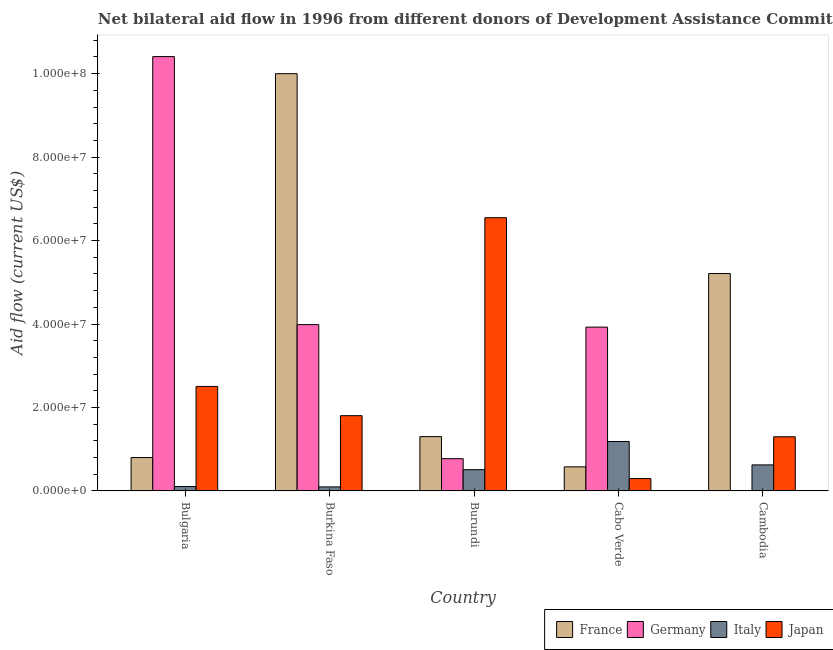How many different coloured bars are there?
Provide a short and direct response. 4. Are the number of bars on each tick of the X-axis equal?
Make the answer very short. Yes. What is the label of the 2nd group of bars from the left?
Provide a short and direct response. Burkina Faso. In how many cases, is the number of bars for a given country not equal to the number of legend labels?
Offer a very short reply. 0. What is the amount of aid given by germany in Burundi?
Keep it short and to the point. 7.73e+06. Across all countries, what is the maximum amount of aid given by japan?
Your response must be concise. 6.55e+07. Across all countries, what is the minimum amount of aid given by france?
Provide a succinct answer. 5.77e+06. In which country was the amount of aid given by germany maximum?
Your answer should be very brief. Bulgaria. In which country was the amount of aid given by france minimum?
Ensure brevity in your answer.  Cabo Verde. What is the total amount of aid given by italy in the graph?
Make the answer very short. 2.52e+07. What is the difference between the amount of aid given by italy in Bulgaria and that in Burkina Faso?
Provide a short and direct response. 8.00e+04. What is the difference between the amount of aid given by japan in Burundi and the amount of aid given by germany in Cabo Verde?
Offer a terse response. 2.62e+07. What is the average amount of aid given by germany per country?
Offer a very short reply. 3.82e+07. What is the difference between the amount of aid given by japan and amount of aid given by italy in Bulgaria?
Your answer should be very brief. 2.40e+07. In how many countries, is the amount of aid given by france greater than 16000000 US$?
Make the answer very short. 2. What is the ratio of the amount of aid given by japan in Burkina Faso to that in Cabo Verde?
Your answer should be very brief. 6.09. What is the difference between the highest and the second highest amount of aid given by italy?
Your answer should be very brief. 5.61e+06. What is the difference between the highest and the lowest amount of aid given by japan?
Offer a very short reply. 6.25e+07. In how many countries, is the amount of aid given by france greater than the average amount of aid given by france taken over all countries?
Make the answer very short. 2. Is it the case that in every country, the sum of the amount of aid given by france and amount of aid given by italy is greater than the sum of amount of aid given by germany and amount of aid given by japan?
Ensure brevity in your answer.  No. What does the 1st bar from the left in Burkina Faso represents?
Your answer should be compact. France. What does the 2nd bar from the right in Bulgaria represents?
Your answer should be compact. Italy. Where does the legend appear in the graph?
Keep it short and to the point. Bottom right. How many legend labels are there?
Provide a short and direct response. 4. How are the legend labels stacked?
Offer a terse response. Horizontal. What is the title of the graph?
Your answer should be very brief. Net bilateral aid flow in 1996 from different donors of Development Assistance Committee. Does "Insurance services" appear as one of the legend labels in the graph?
Provide a succinct answer. No. What is the Aid flow (current US$) of Germany in Bulgaria?
Offer a terse response. 1.04e+08. What is the Aid flow (current US$) of Italy in Bulgaria?
Ensure brevity in your answer.  1.05e+06. What is the Aid flow (current US$) of Japan in Bulgaria?
Your response must be concise. 2.50e+07. What is the Aid flow (current US$) in France in Burkina Faso?
Give a very brief answer. 1.00e+08. What is the Aid flow (current US$) in Germany in Burkina Faso?
Offer a very short reply. 3.99e+07. What is the Aid flow (current US$) of Italy in Burkina Faso?
Provide a short and direct response. 9.70e+05. What is the Aid flow (current US$) in Japan in Burkina Faso?
Provide a short and direct response. 1.80e+07. What is the Aid flow (current US$) in France in Burundi?
Your response must be concise. 1.30e+07. What is the Aid flow (current US$) of Germany in Burundi?
Provide a short and direct response. 7.73e+06. What is the Aid flow (current US$) in Italy in Burundi?
Your answer should be compact. 5.10e+06. What is the Aid flow (current US$) in Japan in Burundi?
Provide a short and direct response. 6.55e+07. What is the Aid flow (current US$) of France in Cabo Verde?
Make the answer very short. 5.77e+06. What is the Aid flow (current US$) in Germany in Cabo Verde?
Provide a short and direct response. 3.93e+07. What is the Aid flow (current US$) of Italy in Cabo Verde?
Make the answer very short. 1.18e+07. What is the Aid flow (current US$) in Japan in Cabo Verde?
Give a very brief answer. 2.96e+06. What is the Aid flow (current US$) of France in Cambodia?
Keep it short and to the point. 5.21e+07. What is the Aid flow (current US$) of Germany in Cambodia?
Your answer should be compact. 2.00e+04. What is the Aid flow (current US$) in Italy in Cambodia?
Give a very brief answer. 6.24e+06. What is the Aid flow (current US$) in Japan in Cambodia?
Offer a terse response. 1.30e+07. Across all countries, what is the maximum Aid flow (current US$) of France?
Your response must be concise. 1.00e+08. Across all countries, what is the maximum Aid flow (current US$) of Germany?
Offer a very short reply. 1.04e+08. Across all countries, what is the maximum Aid flow (current US$) of Italy?
Your answer should be very brief. 1.18e+07. Across all countries, what is the maximum Aid flow (current US$) of Japan?
Your answer should be compact. 6.55e+07. Across all countries, what is the minimum Aid flow (current US$) of France?
Provide a short and direct response. 5.77e+06. Across all countries, what is the minimum Aid flow (current US$) in Germany?
Offer a very short reply. 2.00e+04. Across all countries, what is the minimum Aid flow (current US$) of Italy?
Give a very brief answer. 9.70e+05. Across all countries, what is the minimum Aid flow (current US$) in Japan?
Ensure brevity in your answer.  2.96e+06. What is the total Aid flow (current US$) in France in the graph?
Offer a very short reply. 1.79e+08. What is the total Aid flow (current US$) in Germany in the graph?
Provide a succinct answer. 1.91e+08. What is the total Aid flow (current US$) in Italy in the graph?
Give a very brief answer. 2.52e+07. What is the total Aid flow (current US$) in Japan in the graph?
Provide a short and direct response. 1.24e+08. What is the difference between the Aid flow (current US$) in France in Bulgaria and that in Burkina Faso?
Keep it short and to the point. -9.20e+07. What is the difference between the Aid flow (current US$) of Germany in Bulgaria and that in Burkina Faso?
Give a very brief answer. 6.42e+07. What is the difference between the Aid flow (current US$) of France in Bulgaria and that in Burundi?
Offer a very short reply. -5.02e+06. What is the difference between the Aid flow (current US$) of Germany in Bulgaria and that in Burundi?
Make the answer very short. 9.64e+07. What is the difference between the Aid flow (current US$) of Italy in Bulgaria and that in Burundi?
Your response must be concise. -4.05e+06. What is the difference between the Aid flow (current US$) of Japan in Bulgaria and that in Burundi?
Keep it short and to the point. -4.04e+07. What is the difference between the Aid flow (current US$) of France in Bulgaria and that in Cabo Verde?
Your answer should be very brief. 2.23e+06. What is the difference between the Aid flow (current US$) in Germany in Bulgaria and that in Cabo Verde?
Keep it short and to the point. 6.48e+07. What is the difference between the Aid flow (current US$) of Italy in Bulgaria and that in Cabo Verde?
Provide a short and direct response. -1.08e+07. What is the difference between the Aid flow (current US$) in Japan in Bulgaria and that in Cabo Verde?
Offer a terse response. 2.21e+07. What is the difference between the Aid flow (current US$) in France in Bulgaria and that in Cambodia?
Ensure brevity in your answer.  -4.41e+07. What is the difference between the Aid flow (current US$) of Germany in Bulgaria and that in Cambodia?
Your answer should be very brief. 1.04e+08. What is the difference between the Aid flow (current US$) of Italy in Bulgaria and that in Cambodia?
Offer a terse response. -5.19e+06. What is the difference between the Aid flow (current US$) in Japan in Bulgaria and that in Cambodia?
Give a very brief answer. 1.21e+07. What is the difference between the Aid flow (current US$) of France in Burkina Faso and that in Burundi?
Your answer should be compact. 8.70e+07. What is the difference between the Aid flow (current US$) in Germany in Burkina Faso and that in Burundi?
Provide a succinct answer. 3.21e+07. What is the difference between the Aid flow (current US$) of Italy in Burkina Faso and that in Burundi?
Provide a short and direct response. -4.13e+06. What is the difference between the Aid flow (current US$) in Japan in Burkina Faso and that in Burundi?
Provide a succinct answer. -4.74e+07. What is the difference between the Aid flow (current US$) of France in Burkina Faso and that in Cabo Verde?
Ensure brevity in your answer.  9.42e+07. What is the difference between the Aid flow (current US$) of Germany in Burkina Faso and that in Cabo Verde?
Make the answer very short. 6.00e+05. What is the difference between the Aid flow (current US$) in Italy in Burkina Faso and that in Cabo Verde?
Your answer should be very brief. -1.09e+07. What is the difference between the Aid flow (current US$) in Japan in Burkina Faso and that in Cabo Verde?
Ensure brevity in your answer.  1.51e+07. What is the difference between the Aid flow (current US$) of France in Burkina Faso and that in Cambodia?
Your response must be concise. 4.79e+07. What is the difference between the Aid flow (current US$) of Germany in Burkina Faso and that in Cambodia?
Provide a succinct answer. 3.98e+07. What is the difference between the Aid flow (current US$) of Italy in Burkina Faso and that in Cambodia?
Your answer should be very brief. -5.27e+06. What is the difference between the Aid flow (current US$) of Japan in Burkina Faso and that in Cambodia?
Your answer should be compact. 5.06e+06. What is the difference between the Aid flow (current US$) of France in Burundi and that in Cabo Verde?
Offer a very short reply. 7.25e+06. What is the difference between the Aid flow (current US$) of Germany in Burundi and that in Cabo Verde?
Your response must be concise. -3.15e+07. What is the difference between the Aid flow (current US$) in Italy in Burundi and that in Cabo Verde?
Keep it short and to the point. -6.75e+06. What is the difference between the Aid flow (current US$) of Japan in Burundi and that in Cabo Verde?
Give a very brief answer. 6.25e+07. What is the difference between the Aid flow (current US$) of France in Burundi and that in Cambodia?
Your answer should be very brief. -3.91e+07. What is the difference between the Aid flow (current US$) in Germany in Burundi and that in Cambodia?
Provide a succinct answer. 7.71e+06. What is the difference between the Aid flow (current US$) in Italy in Burundi and that in Cambodia?
Keep it short and to the point. -1.14e+06. What is the difference between the Aid flow (current US$) in Japan in Burundi and that in Cambodia?
Ensure brevity in your answer.  5.25e+07. What is the difference between the Aid flow (current US$) in France in Cabo Verde and that in Cambodia?
Your answer should be compact. -4.63e+07. What is the difference between the Aid flow (current US$) in Germany in Cabo Verde and that in Cambodia?
Provide a short and direct response. 3.92e+07. What is the difference between the Aid flow (current US$) of Italy in Cabo Verde and that in Cambodia?
Provide a short and direct response. 5.61e+06. What is the difference between the Aid flow (current US$) in Japan in Cabo Verde and that in Cambodia?
Ensure brevity in your answer.  -1.00e+07. What is the difference between the Aid flow (current US$) in France in Bulgaria and the Aid flow (current US$) in Germany in Burkina Faso?
Offer a very short reply. -3.19e+07. What is the difference between the Aid flow (current US$) in France in Bulgaria and the Aid flow (current US$) in Italy in Burkina Faso?
Ensure brevity in your answer.  7.03e+06. What is the difference between the Aid flow (current US$) of France in Bulgaria and the Aid flow (current US$) of Japan in Burkina Faso?
Your answer should be compact. -1.00e+07. What is the difference between the Aid flow (current US$) of Germany in Bulgaria and the Aid flow (current US$) of Italy in Burkina Faso?
Keep it short and to the point. 1.03e+08. What is the difference between the Aid flow (current US$) of Germany in Bulgaria and the Aid flow (current US$) of Japan in Burkina Faso?
Your answer should be compact. 8.60e+07. What is the difference between the Aid flow (current US$) of Italy in Bulgaria and the Aid flow (current US$) of Japan in Burkina Faso?
Offer a very short reply. -1.70e+07. What is the difference between the Aid flow (current US$) in France in Bulgaria and the Aid flow (current US$) in Italy in Burundi?
Offer a terse response. 2.90e+06. What is the difference between the Aid flow (current US$) in France in Bulgaria and the Aid flow (current US$) in Japan in Burundi?
Provide a short and direct response. -5.75e+07. What is the difference between the Aid flow (current US$) in Germany in Bulgaria and the Aid flow (current US$) in Italy in Burundi?
Offer a terse response. 9.90e+07. What is the difference between the Aid flow (current US$) in Germany in Bulgaria and the Aid flow (current US$) in Japan in Burundi?
Give a very brief answer. 3.86e+07. What is the difference between the Aid flow (current US$) in Italy in Bulgaria and the Aid flow (current US$) in Japan in Burundi?
Make the answer very short. -6.44e+07. What is the difference between the Aid flow (current US$) of France in Bulgaria and the Aid flow (current US$) of Germany in Cabo Verde?
Your answer should be very brief. -3.13e+07. What is the difference between the Aid flow (current US$) in France in Bulgaria and the Aid flow (current US$) in Italy in Cabo Verde?
Your response must be concise. -3.85e+06. What is the difference between the Aid flow (current US$) in France in Bulgaria and the Aid flow (current US$) in Japan in Cabo Verde?
Offer a terse response. 5.04e+06. What is the difference between the Aid flow (current US$) of Germany in Bulgaria and the Aid flow (current US$) of Italy in Cabo Verde?
Offer a terse response. 9.22e+07. What is the difference between the Aid flow (current US$) of Germany in Bulgaria and the Aid flow (current US$) of Japan in Cabo Verde?
Your answer should be very brief. 1.01e+08. What is the difference between the Aid flow (current US$) in Italy in Bulgaria and the Aid flow (current US$) in Japan in Cabo Verde?
Make the answer very short. -1.91e+06. What is the difference between the Aid flow (current US$) in France in Bulgaria and the Aid flow (current US$) in Germany in Cambodia?
Provide a short and direct response. 7.98e+06. What is the difference between the Aid flow (current US$) of France in Bulgaria and the Aid flow (current US$) of Italy in Cambodia?
Offer a terse response. 1.76e+06. What is the difference between the Aid flow (current US$) in France in Bulgaria and the Aid flow (current US$) in Japan in Cambodia?
Keep it short and to the point. -4.98e+06. What is the difference between the Aid flow (current US$) in Germany in Bulgaria and the Aid flow (current US$) in Italy in Cambodia?
Offer a terse response. 9.78e+07. What is the difference between the Aid flow (current US$) in Germany in Bulgaria and the Aid flow (current US$) in Japan in Cambodia?
Provide a succinct answer. 9.11e+07. What is the difference between the Aid flow (current US$) in Italy in Bulgaria and the Aid flow (current US$) in Japan in Cambodia?
Keep it short and to the point. -1.19e+07. What is the difference between the Aid flow (current US$) in France in Burkina Faso and the Aid flow (current US$) in Germany in Burundi?
Provide a succinct answer. 9.23e+07. What is the difference between the Aid flow (current US$) in France in Burkina Faso and the Aid flow (current US$) in Italy in Burundi?
Make the answer very short. 9.49e+07. What is the difference between the Aid flow (current US$) in France in Burkina Faso and the Aid flow (current US$) in Japan in Burundi?
Offer a very short reply. 3.45e+07. What is the difference between the Aid flow (current US$) of Germany in Burkina Faso and the Aid flow (current US$) of Italy in Burundi?
Make the answer very short. 3.48e+07. What is the difference between the Aid flow (current US$) in Germany in Burkina Faso and the Aid flow (current US$) in Japan in Burundi?
Your answer should be compact. -2.56e+07. What is the difference between the Aid flow (current US$) in Italy in Burkina Faso and the Aid flow (current US$) in Japan in Burundi?
Provide a succinct answer. -6.45e+07. What is the difference between the Aid flow (current US$) in France in Burkina Faso and the Aid flow (current US$) in Germany in Cabo Verde?
Provide a short and direct response. 6.07e+07. What is the difference between the Aid flow (current US$) of France in Burkina Faso and the Aid flow (current US$) of Italy in Cabo Verde?
Give a very brief answer. 8.82e+07. What is the difference between the Aid flow (current US$) in France in Burkina Faso and the Aid flow (current US$) in Japan in Cabo Verde?
Provide a short and direct response. 9.70e+07. What is the difference between the Aid flow (current US$) of Germany in Burkina Faso and the Aid flow (current US$) of Italy in Cabo Verde?
Give a very brief answer. 2.80e+07. What is the difference between the Aid flow (current US$) in Germany in Burkina Faso and the Aid flow (current US$) in Japan in Cabo Verde?
Provide a short and direct response. 3.69e+07. What is the difference between the Aid flow (current US$) of Italy in Burkina Faso and the Aid flow (current US$) of Japan in Cabo Verde?
Your response must be concise. -1.99e+06. What is the difference between the Aid flow (current US$) in France in Burkina Faso and the Aid flow (current US$) in Germany in Cambodia?
Offer a terse response. 1.00e+08. What is the difference between the Aid flow (current US$) in France in Burkina Faso and the Aid flow (current US$) in Italy in Cambodia?
Give a very brief answer. 9.38e+07. What is the difference between the Aid flow (current US$) in France in Burkina Faso and the Aid flow (current US$) in Japan in Cambodia?
Provide a short and direct response. 8.70e+07. What is the difference between the Aid flow (current US$) in Germany in Burkina Faso and the Aid flow (current US$) in Italy in Cambodia?
Ensure brevity in your answer.  3.36e+07. What is the difference between the Aid flow (current US$) in Germany in Burkina Faso and the Aid flow (current US$) in Japan in Cambodia?
Ensure brevity in your answer.  2.69e+07. What is the difference between the Aid flow (current US$) of Italy in Burkina Faso and the Aid flow (current US$) of Japan in Cambodia?
Your answer should be compact. -1.20e+07. What is the difference between the Aid flow (current US$) of France in Burundi and the Aid flow (current US$) of Germany in Cabo Verde?
Offer a very short reply. -2.62e+07. What is the difference between the Aid flow (current US$) of France in Burundi and the Aid flow (current US$) of Italy in Cabo Verde?
Offer a terse response. 1.17e+06. What is the difference between the Aid flow (current US$) of France in Burundi and the Aid flow (current US$) of Japan in Cabo Verde?
Provide a short and direct response. 1.01e+07. What is the difference between the Aid flow (current US$) in Germany in Burundi and the Aid flow (current US$) in Italy in Cabo Verde?
Provide a succinct answer. -4.12e+06. What is the difference between the Aid flow (current US$) in Germany in Burundi and the Aid flow (current US$) in Japan in Cabo Verde?
Make the answer very short. 4.77e+06. What is the difference between the Aid flow (current US$) in Italy in Burundi and the Aid flow (current US$) in Japan in Cabo Verde?
Provide a short and direct response. 2.14e+06. What is the difference between the Aid flow (current US$) in France in Burundi and the Aid flow (current US$) in Germany in Cambodia?
Offer a very short reply. 1.30e+07. What is the difference between the Aid flow (current US$) in France in Burundi and the Aid flow (current US$) in Italy in Cambodia?
Your answer should be compact. 6.78e+06. What is the difference between the Aid flow (current US$) of France in Burundi and the Aid flow (current US$) of Japan in Cambodia?
Your response must be concise. 4.00e+04. What is the difference between the Aid flow (current US$) in Germany in Burundi and the Aid flow (current US$) in Italy in Cambodia?
Your answer should be compact. 1.49e+06. What is the difference between the Aid flow (current US$) in Germany in Burundi and the Aid flow (current US$) in Japan in Cambodia?
Provide a short and direct response. -5.25e+06. What is the difference between the Aid flow (current US$) in Italy in Burundi and the Aid flow (current US$) in Japan in Cambodia?
Offer a very short reply. -7.88e+06. What is the difference between the Aid flow (current US$) in France in Cabo Verde and the Aid flow (current US$) in Germany in Cambodia?
Provide a succinct answer. 5.75e+06. What is the difference between the Aid flow (current US$) in France in Cabo Verde and the Aid flow (current US$) in Italy in Cambodia?
Provide a succinct answer. -4.70e+05. What is the difference between the Aid flow (current US$) of France in Cabo Verde and the Aid flow (current US$) of Japan in Cambodia?
Ensure brevity in your answer.  -7.21e+06. What is the difference between the Aid flow (current US$) in Germany in Cabo Verde and the Aid flow (current US$) in Italy in Cambodia?
Offer a very short reply. 3.30e+07. What is the difference between the Aid flow (current US$) of Germany in Cabo Verde and the Aid flow (current US$) of Japan in Cambodia?
Ensure brevity in your answer.  2.63e+07. What is the difference between the Aid flow (current US$) in Italy in Cabo Verde and the Aid flow (current US$) in Japan in Cambodia?
Offer a very short reply. -1.13e+06. What is the average Aid flow (current US$) in France per country?
Make the answer very short. 3.58e+07. What is the average Aid flow (current US$) of Germany per country?
Your answer should be compact. 3.82e+07. What is the average Aid flow (current US$) in Italy per country?
Offer a terse response. 5.04e+06. What is the average Aid flow (current US$) of Japan per country?
Offer a terse response. 2.49e+07. What is the difference between the Aid flow (current US$) of France and Aid flow (current US$) of Germany in Bulgaria?
Make the answer very short. -9.61e+07. What is the difference between the Aid flow (current US$) in France and Aid flow (current US$) in Italy in Bulgaria?
Offer a terse response. 6.95e+06. What is the difference between the Aid flow (current US$) of France and Aid flow (current US$) of Japan in Bulgaria?
Offer a terse response. -1.70e+07. What is the difference between the Aid flow (current US$) of Germany and Aid flow (current US$) of Italy in Bulgaria?
Make the answer very short. 1.03e+08. What is the difference between the Aid flow (current US$) of Germany and Aid flow (current US$) of Japan in Bulgaria?
Keep it short and to the point. 7.90e+07. What is the difference between the Aid flow (current US$) of Italy and Aid flow (current US$) of Japan in Bulgaria?
Offer a very short reply. -2.40e+07. What is the difference between the Aid flow (current US$) of France and Aid flow (current US$) of Germany in Burkina Faso?
Your answer should be compact. 6.01e+07. What is the difference between the Aid flow (current US$) in France and Aid flow (current US$) in Italy in Burkina Faso?
Provide a short and direct response. 9.90e+07. What is the difference between the Aid flow (current US$) in France and Aid flow (current US$) in Japan in Burkina Faso?
Your response must be concise. 8.20e+07. What is the difference between the Aid flow (current US$) of Germany and Aid flow (current US$) of Italy in Burkina Faso?
Ensure brevity in your answer.  3.89e+07. What is the difference between the Aid flow (current US$) of Germany and Aid flow (current US$) of Japan in Burkina Faso?
Your response must be concise. 2.18e+07. What is the difference between the Aid flow (current US$) in Italy and Aid flow (current US$) in Japan in Burkina Faso?
Give a very brief answer. -1.71e+07. What is the difference between the Aid flow (current US$) in France and Aid flow (current US$) in Germany in Burundi?
Your answer should be very brief. 5.29e+06. What is the difference between the Aid flow (current US$) of France and Aid flow (current US$) of Italy in Burundi?
Give a very brief answer. 7.92e+06. What is the difference between the Aid flow (current US$) in France and Aid flow (current US$) in Japan in Burundi?
Ensure brevity in your answer.  -5.25e+07. What is the difference between the Aid flow (current US$) in Germany and Aid flow (current US$) in Italy in Burundi?
Your answer should be compact. 2.63e+06. What is the difference between the Aid flow (current US$) in Germany and Aid flow (current US$) in Japan in Burundi?
Your answer should be compact. -5.78e+07. What is the difference between the Aid flow (current US$) of Italy and Aid flow (current US$) of Japan in Burundi?
Your answer should be very brief. -6.04e+07. What is the difference between the Aid flow (current US$) in France and Aid flow (current US$) in Germany in Cabo Verde?
Your answer should be very brief. -3.35e+07. What is the difference between the Aid flow (current US$) in France and Aid flow (current US$) in Italy in Cabo Verde?
Your answer should be very brief. -6.08e+06. What is the difference between the Aid flow (current US$) of France and Aid flow (current US$) of Japan in Cabo Verde?
Provide a succinct answer. 2.81e+06. What is the difference between the Aid flow (current US$) in Germany and Aid flow (current US$) in Italy in Cabo Verde?
Your answer should be very brief. 2.74e+07. What is the difference between the Aid flow (current US$) in Germany and Aid flow (current US$) in Japan in Cabo Verde?
Provide a succinct answer. 3.63e+07. What is the difference between the Aid flow (current US$) in Italy and Aid flow (current US$) in Japan in Cabo Verde?
Your answer should be very brief. 8.89e+06. What is the difference between the Aid flow (current US$) in France and Aid flow (current US$) in Germany in Cambodia?
Ensure brevity in your answer.  5.21e+07. What is the difference between the Aid flow (current US$) of France and Aid flow (current US$) of Italy in Cambodia?
Make the answer very short. 4.59e+07. What is the difference between the Aid flow (current US$) of France and Aid flow (current US$) of Japan in Cambodia?
Your answer should be very brief. 3.91e+07. What is the difference between the Aid flow (current US$) in Germany and Aid flow (current US$) in Italy in Cambodia?
Your answer should be very brief. -6.22e+06. What is the difference between the Aid flow (current US$) in Germany and Aid flow (current US$) in Japan in Cambodia?
Give a very brief answer. -1.30e+07. What is the difference between the Aid flow (current US$) of Italy and Aid flow (current US$) of Japan in Cambodia?
Offer a terse response. -6.74e+06. What is the ratio of the Aid flow (current US$) in Germany in Bulgaria to that in Burkina Faso?
Keep it short and to the point. 2.61. What is the ratio of the Aid flow (current US$) in Italy in Bulgaria to that in Burkina Faso?
Offer a terse response. 1.08. What is the ratio of the Aid flow (current US$) of Japan in Bulgaria to that in Burkina Faso?
Your answer should be compact. 1.39. What is the ratio of the Aid flow (current US$) in France in Bulgaria to that in Burundi?
Offer a very short reply. 0.61. What is the ratio of the Aid flow (current US$) in Germany in Bulgaria to that in Burundi?
Your answer should be compact. 13.47. What is the ratio of the Aid flow (current US$) in Italy in Bulgaria to that in Burundi?
Your answer should be compact. 0.21. What is the ratio of the Aid flow (current US$) in Japan in Bulgaria to that in Burundi?
Make the answer very short. 0.38. What is the ratio of the Aid flow (current US$) in France in Bulgaria to that in Cabo Verde?
Offer a very short reply. 1.39. What is the ratio of the Aid flow (current US$) in Germany in Bulgaria to that in Cabo Verde?
Offer a very short reply. 2.65. What is the ratio of the Aid flow (current US$) of Italy in Bulgaria to that in Cabo Verde?
Give a very brief answer. 0.09. What is the ratio of the Aid flow (current US$) of Japan in Bulgaria to that in Cabo Verde?
Keep it short and to the point. 8.46. What is the ratio of the Aid flow (current US$) of France in Bulgaria to that in Cambodia?
Keep it short and to the point. 0.15. What is the ratio of the Aid flow (current US$) in Germany in Bulgaria to that in Cambodia?
Keep it short and to the point. 5204.5. What is the ratio of the Aid flow (current US$) of Italy in Bulgaria to that in Cambodia?
Ensure brevity in your answer.  0.17. What is the ratio of the Aid flow (current US$) of Japan in Bulgaria to that in Cambodia?
Offer a very short reply. 1.93. What is the ratio of the Aid flow (current US$) of France in Burkina Faso to that in Burundi?
Provide a succinct answer. 7.68. What is the ratio of the Aid flow (current US$) in Germany in Burkina Faso to that in Burundi?
Your response must be concise. 5.16. What is the ratio of the Aid flow (current US$) of Italy in Burkina Faso to that in Burundi?
Offer a very short reply. 0.19. What is the ratio of the Aid flow (current US$) in Japan in Burkina Faso to that in Burundi?
Ensure brevity in your answer.  0.28. What is the ratio of the Aid flow (current US$) of France in Burkina Faso to that in Cabo Verde?
Offer a very short reply. 17.33. What is the ratio of the Aid flow (current US$) in Germany in Burkina Faso to that in Cabo Verde?
Offer a very short reply. 1.02. What is the ratio of the Aid flow (current US$) of Italy in Burkina Faso to that in Cabo Verde?
Offer a terse response. 0.08. What is the ratio of the Aid flow (current US$) in Japan in Burkina Faso to that in Cabo Verde?
Your answer should be compact. 6.09. What is the ratio of the Aid flow (current US$) in France in Burkina Faso to that in Cambodia?
Provide a short and direct response. 1.92. What is the ratio of the Aid flow (current US$) of Germany in Burkina Faso to that in Cambodia?
Provide a succinct answer. 1993. What is the ratio of the Aid flow (current US$) in Italy in Burkina Faso to that in Cambodia?
Offer a terse response. 0.16. What is the ratio of the Aid flow (current US$) of Japan in Burkina Faso to that in Cambodia?
Ensure brevity in your answer.  1.39. What is the ratio of the Aid flow (current US$) in France in Burundi to that in Cabo Verde?
Provide a short and direct response. 2.26. What is the ratio of the Aid flow (current US$) of Germany in Burundi to that in Cabo Verde?
Give a very brief answer. 0.2. What is the ratio of the Aid flow (current US$) of Italy in Burundi to that in Cabo Verde?
Your answer should be compact. 0.43. What is the ratio of the Aid flow (current US$) in Japan in Burundi to that in Cabo Verde?
Ensure brevity in your answer.  22.12. What is the ratio of the Aid flow (current US$) in France in Burundi to that in Cambodia?
Offer a very short reply. 0.25. What is the ratio of the Aid flow (current US$) in Germany in Burundi to that in Cambodia?
Your response must be concise. 386.5. What is the ratio of the Aid flow (current US$) of Italy in Burundi to that in Cambodia?
Offer a very short reply. 0.82. What is the ratio of the Aid flow (current US$) of Japan in Burundi to that in Cambodia?
Your answer should be very brief. 5.04. What is the ratio of the Aid flow (current US$) in France in Cabo Verde to that in Cambodia?
Provide a short and direct response. 0.11. What is the ratio of the Aid flow (current US$) of Germany in Cabo Verde to that in Cambodia?
Provide a succinct answer. 1963. What is the ratio of the Aid flow (current US$) of Italy in Cabo Verde to that in Cambodia?
Your answer should be compact. 1.9. What is the ratio of the Aid flow (current US$) in Japan in Cabo Verde to that in Cambodia?
Give a very brief answer. 0.23. What is the difference between the highest and the second highest Aid flow (current US$) of France?
Your answer should be compact. 4.79e+07. What is the difference between the highest and the second highest Aid flow (current US$) in Germany?
Offer a very short reply. 6.42e+07. What is the difference between the highest and the second highest Aid flow (current US$) of Italy?
Your answer should be very brief. 5.61e+06. What is the difference between the highest and the second highest Aid flow (current US$) in Japan?
Provide a succinct answer. 4.04e+07. What is the difference between the highest and the lowest Aid flow (current US$) in France?
Your answer should be compact. 9.42e+07. What is the difference between the highest and the lowest Aid flow (current US$) in Germany?
Offer a terse response. 1.04e+08. What is the difference between the highest and the lowest Aid flow (current US$) of Italy?
Your answer should be compact. 1.09e+07. What is the difference between the highest and the lowest Aid flow (current US$) of Japan?
Provide a short and direct response. 6.25e+07. 